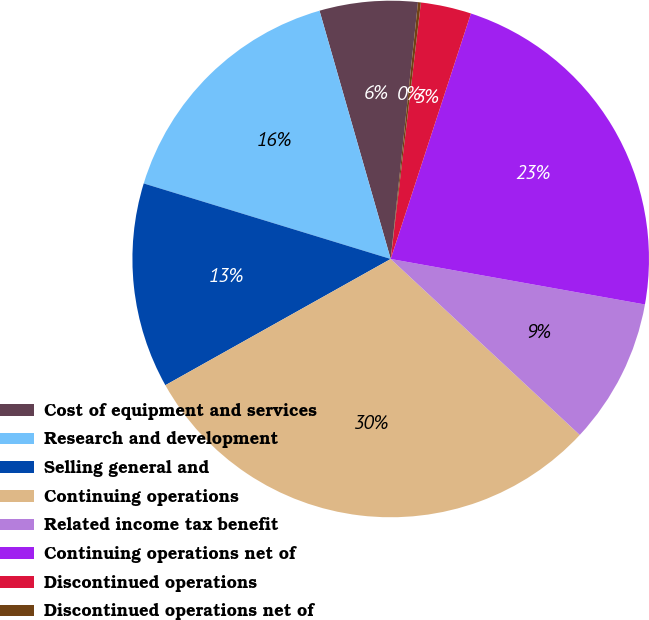Convert chart. <chart><loc_0><loc_0><loc_500><loc_500><pie_chart><fcel>Cost of equipment and services<fcel>Research and development<fcel>Selling general and<fcel>Continuing operations<fcel>Related income tax benefit<fcel>Continuing operations net of<fcel>Discontinued operations<fcel>Discontinued operations net of<nl><fcel>6.13%<fcel>15.83%<fcel>12.85%<fcel>29.94%<fcel>9.11%<fcel>22.79%<fcel>3.16%<fcel>0.18%<nl></chart> 